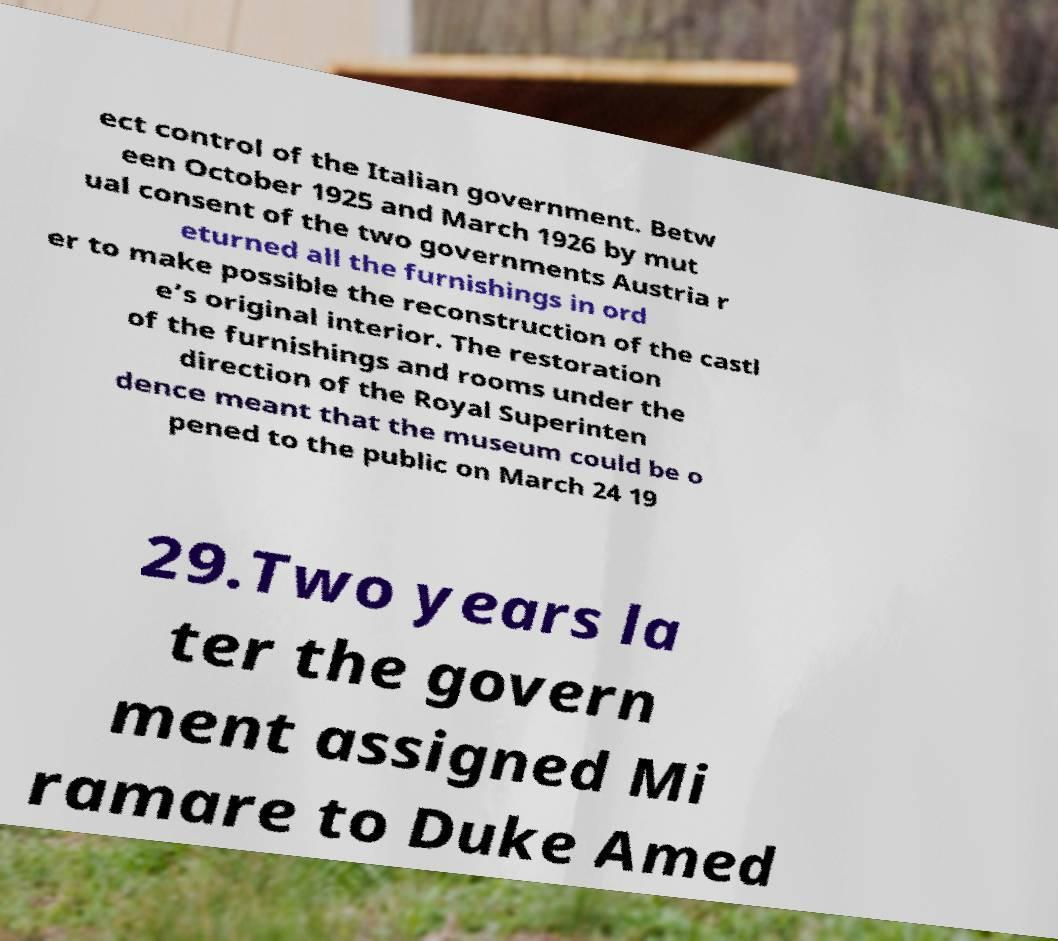I need the written content from this picture converted into text. Can you do that? ect control of the Italian government. Betw een October 1925 and March 1926 by mut ual consent of the two governments Austria r eturned all the furnishings in ord er to make possible the reconstruction of the castl e’s original interior. The restoration of the furnishings and rooms under the direction of the Royal Superinten dence meant that the museum could be o pened to the public on March 24 19 29.Two years la ter the govern ment assigned Mi ramare to Duke Amed 